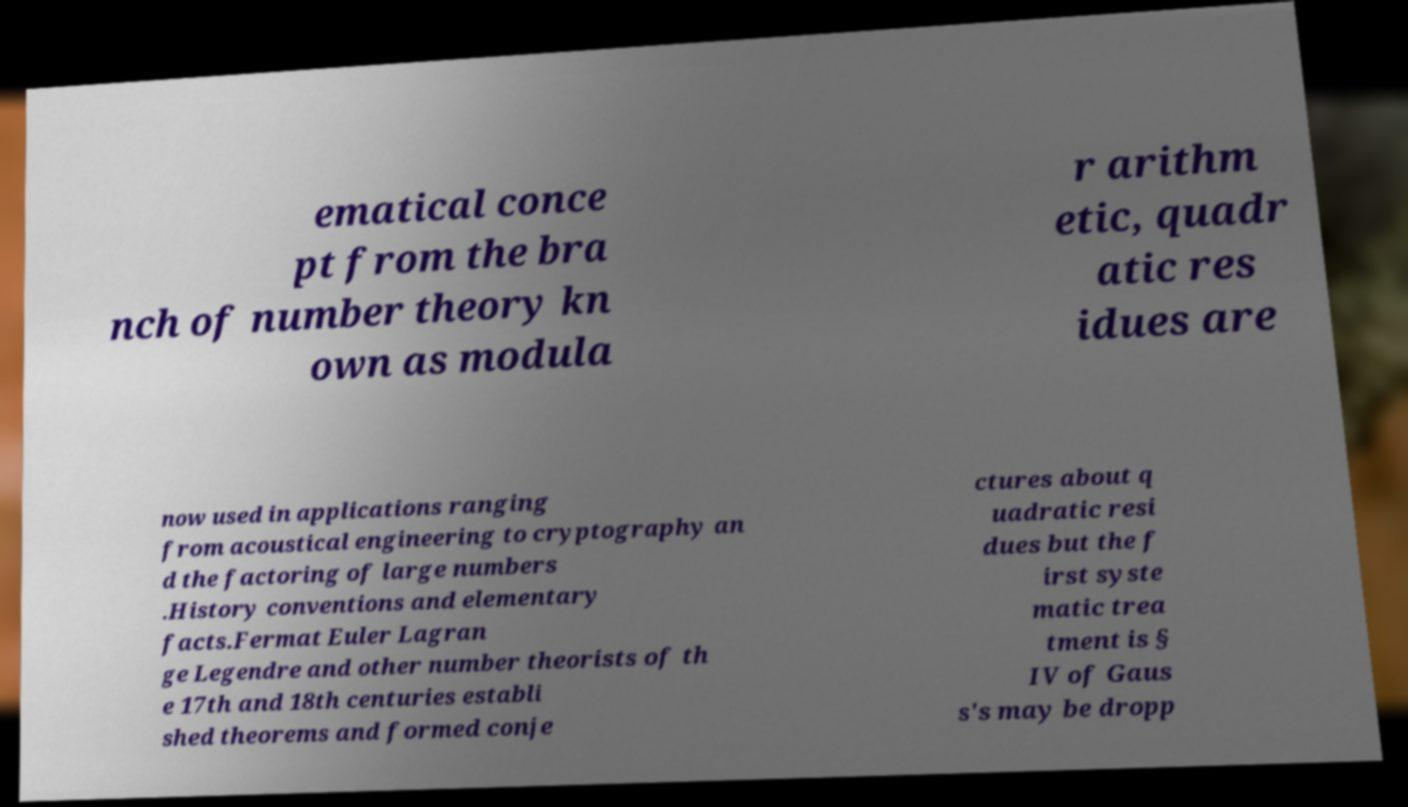Please identify and transcribe the text found in this image. ematical conce pt from the bra nch of number theory kn own as modula r arithm etic, quadr atic res idues are now used in applications ranging from acoustical engineering to cryptography an d the factoring of large numbers .History conventions and elementary facts.Fermat Euler Lagran ge Legendre and other number theorists of th e 17th and 18th centuries establi shed theorems and formed conje ctures about q uadratic resi dues but the f irst syste matic trea tment is § IV of Gaus s's may be dropp 